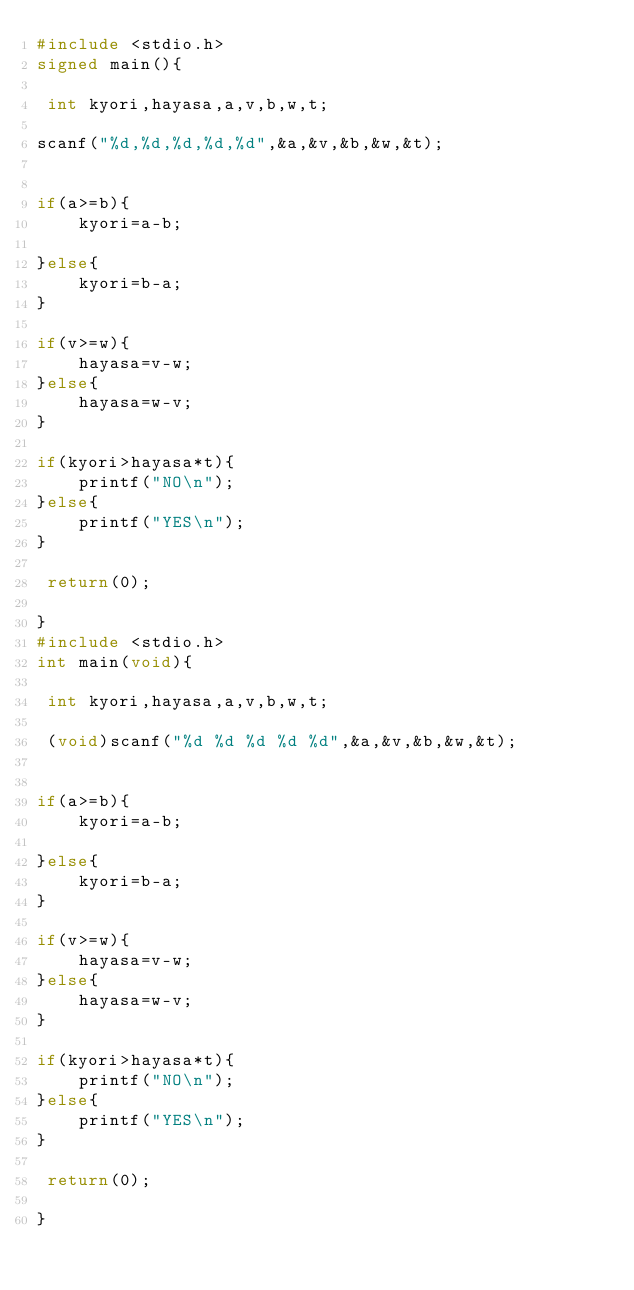Convert code to text. <code><loc_0><loc_0><loc_500><loc_500><_C_>#include <stdio.h>
signed main(){
 
 int kyori,hayasa,a,v,b,w,t;
 
scanf("%d,%d,%d,%d,%d",&a,&v,&b,&w,&t);
 
 
if(a>=b){
    kyori=a-b;
    
}else{
    kyori=b-a;
}
 
if(v>=w){
    hayasa=v-w;    
}else{
    hayasa=w-v;   
}
 
if(kyori>hayasa*t){    
    printf("NO\n");   
}else{
    printf("YES\n");   
}
 
 return(0);
    
}
#include <stdio.h>
int main(void){
 
 int kyori,hayasa,a,v,b,w,t;
 
 (void)scanf("%d %d %d %d %d",&a,&v,&b,&w,&t);
 
 
if(a>=b){
    kyori=a-b;
    
}else{
    kyori=b-a;
}
 
if(v>=w){
    hayasa=v-w;    
}else{
    hayasa=w-v;   
}
 
if(kyori>hayasa*t){    
    printf("NO\n");   
}else{
    printf("YES\n");   
}
 
 return(0);
    
}</code> 